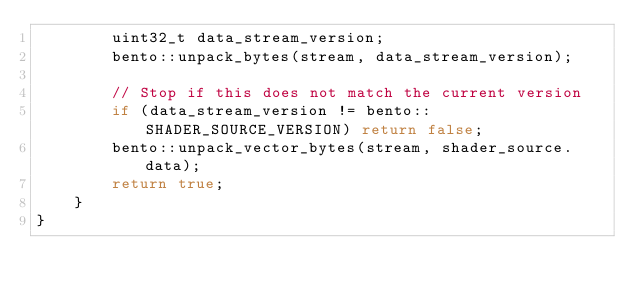<code> <loc_0><loc_0><loc_500><loc_500><_C++_>		uint32_t data_stream_version;
		bento::unpack_bytes(stream, data_stream_version);

		// Stop if this does not match the current version
		if (data_stream_version != bento::SHADER_SOURCE_VERSION) return false;
		bento::unpack_vector_bytes(stream, shader_source.data);
		return true;
	}
}</code> 